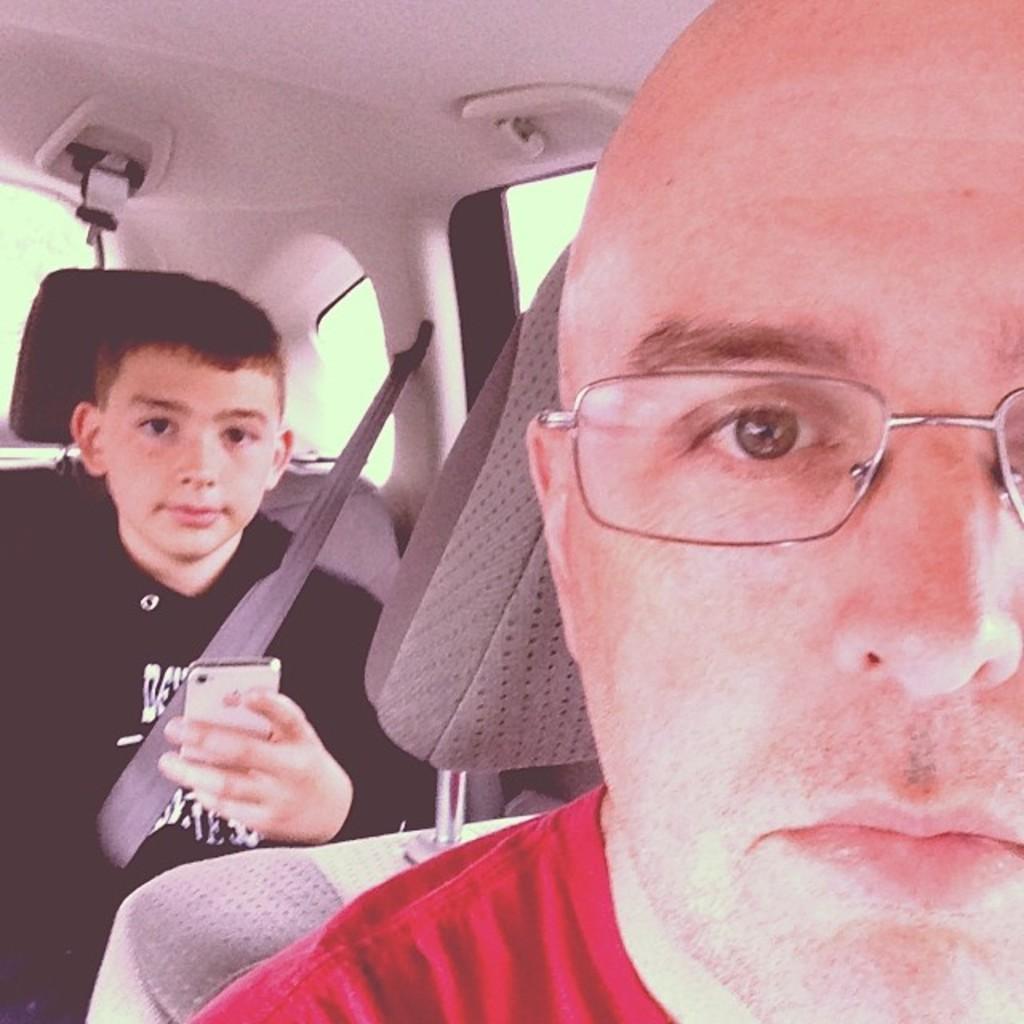In one or two sentences, can you explain what this image depicts? In this picture I can observe two members sitting in the car. One of them is a man wearing spectacles and the other one is a boy holding a mobile in his hand. Boy is wearing seat belt. 